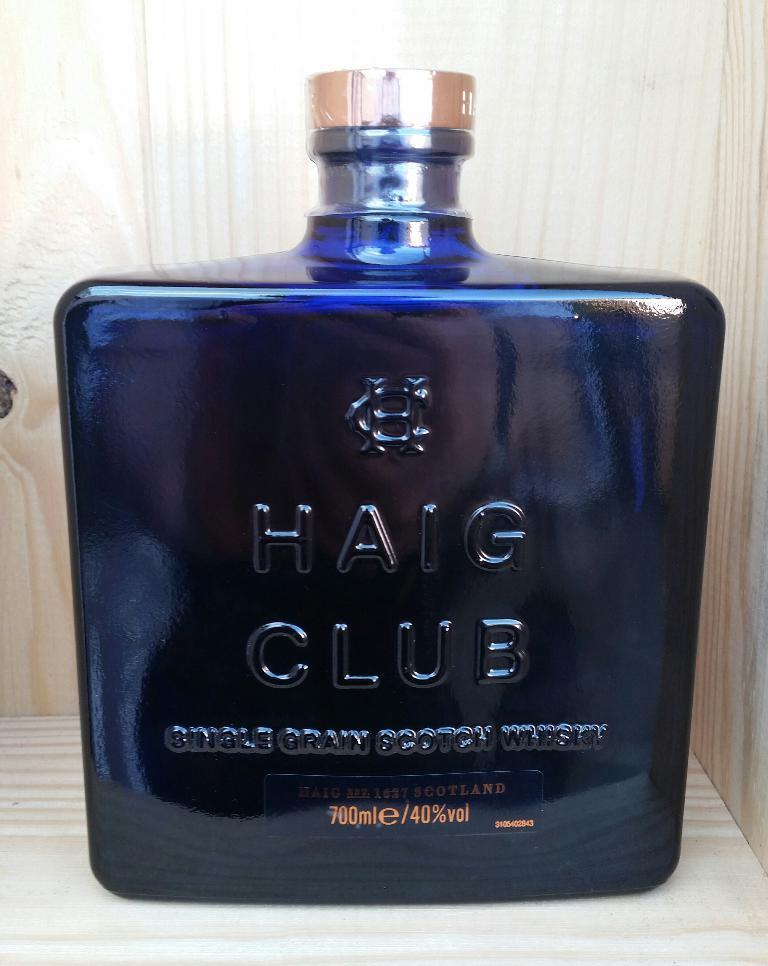<image>
Relay a brief, clear account of the picture shown. HAIG CLUB single grain scotch whisky is from Scotland and comes in an attractive blue bottle. 